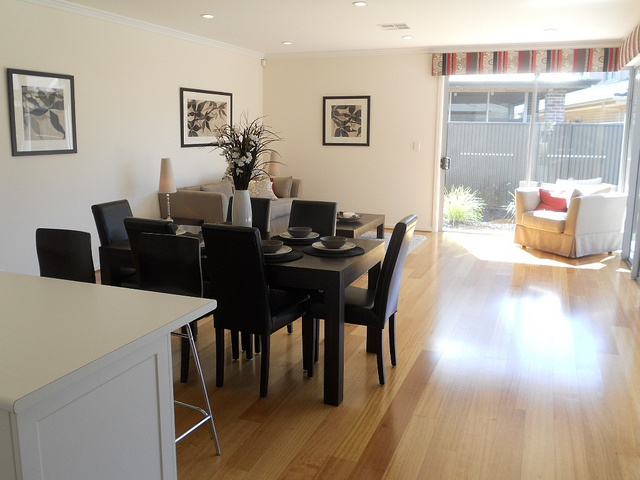Describe the objects in this image and their specific colors. I can see dining table in tan, darkgray, and gray tones, dining table in tan, black, gray, and maroon tones, chair in tan, black, and gray tones, couch in tan, lightgray, and darkgray tones, and chair in tan, black, maroon, and gray tones in this image. 